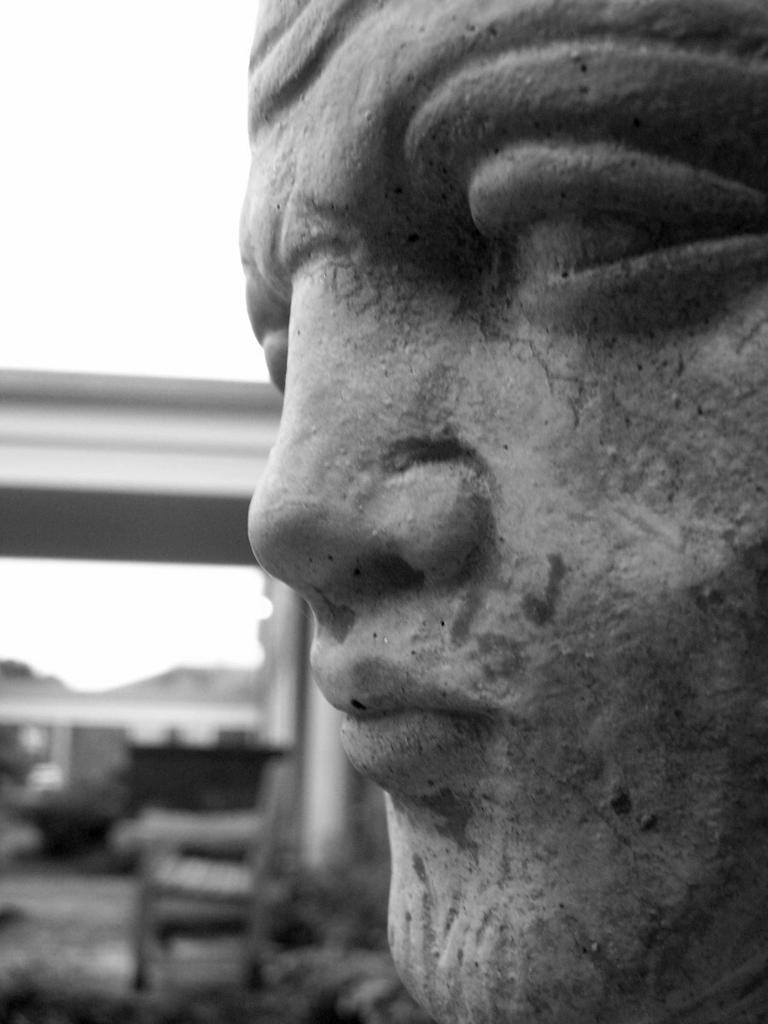What is the color scheme of the image? The image is black and white. What is the main subject in the image? There is a sculpture in the image. Can you describe the background of the image? There are objects in the background of the image. What type of needle is being used by the governor in the image? There is no governor or needle present in the image. 